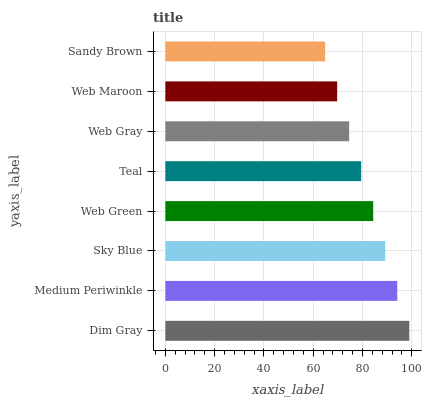Is Sandy Brown the minimum?
Answer yes or no. Yes. Is Dim Gray the maximum?
Answer yes or no. Yes. Is Medium Periwinkle the minimum?
Answer yes or no. No. Is Medium Periwinkle the maximum?
Answer yes or no. No. Is Dim Gray greater than Medium Periwinkle?
Answer yes or no. Yes. Is Medium Periwinkle less than Dim Gray?
Answer yes or no. Yes. Is Medium Periwinkle greater than Dim Gray?
Answer yes or no. No. Is Dim Gray less than Medium Periwinkle?
Answer yes or no. No. Is Web Green the high median?
Answer yes or no. Yes. Is Teal the low median?
Answer yes or no. Yes. Is Teal the high median?
Answer yes or no. No. Is Sandy Brown the low median?
Answer yes or no. No. 